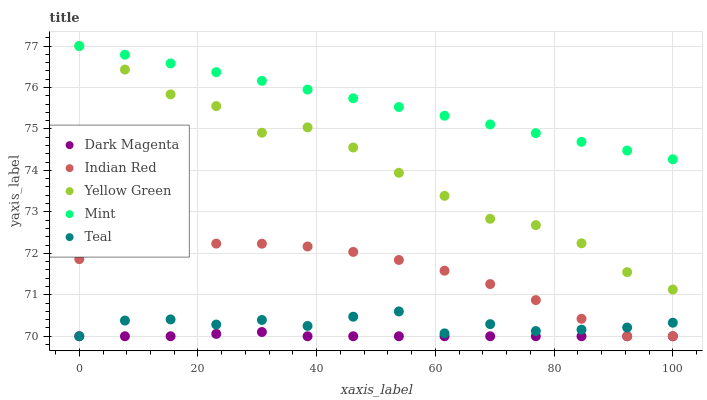Does Dark Magenta have the minimum area under the curve?
Answer yes or no. Yes. Does Mint have the maximum area under the curve?
Answer yes or no. Yes. Does Mint have the minimum area under the curve?
Answer yes or no. No. Does Dark Magenta have the maximum area under the curve?
Answer yes or no. No. Is Mint the smoothest?
Answer yes or no. Yes. Is Teal the roughest?
Answer yes or no. Yes. Is Dark Magenta the smoothest?
Answer yes or no. No. Is Dark Magenta the roughest?
Answer yes or no. No. Does Teal have the lowest value?
Answer yes or no. Yes. Does Mint have the lowest value?
Answer yes or no. No. Does Yellow Green have the highest value?
Answer yes or no. Yes. Does Dark Magenta have the highest value?
Answer yes or no. No. Is Dark Magenta less than Yellow Green?
Answer yes or no. Yes. Is Mint greater than Teal?
Answer yes or no. Yes. Does Mint intersect Yellow Green?
Answer yes or no. Yes. Is Mint less than Yellow Green?
Answer yes or no. No. Is Mint greater than Yellow Green?
Answer yes or no. No. Does Dark Magenta intersect Yellow Green?
Answer yes or no. No. 